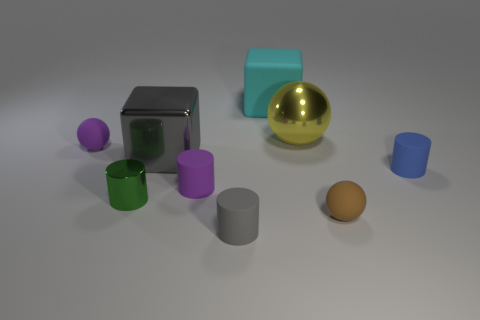There is a large metal object that is right of the tiny gray matte thing; is its shape the same as the blue thing?
Make the answer very short. No. Is there anything else that has the same material as the brown sphere?
Keep it short and to the point. Yes. Do the blue cylinder and the metal object to the right of the tiny purple rubber cylinder have the same size?
Make the answer very short. No. How many other things are the same color as the tiny shiny cylinder?
Your answer should be compact. 0. Are there any shiny things in front of the small gray matte object?
Offer a terse response. No. What number of objects are either blocks or small matte cylinders to the left of the large yellow shiny thing?
Offer a terse response. 4. There is a small purple matte thing behind the gray shiny block; is there a small rubber thing on the left side of it?
Provide a short and direct response. No. There is a shiny object in front of the big block that is on the left side of the matte cylinder in front of the green object; what is its shape?
Ensure brevity in your answer.  Cylinder. There is a matte thing that is both behind the big metallic block and on the right side of the gray shiny cube; what color is it?
Keep it short and to the point. Cyan. What shape is the purple thing that is on the left side of the tiny purple matte cylinder?
Offer a terse response. Sphere. 